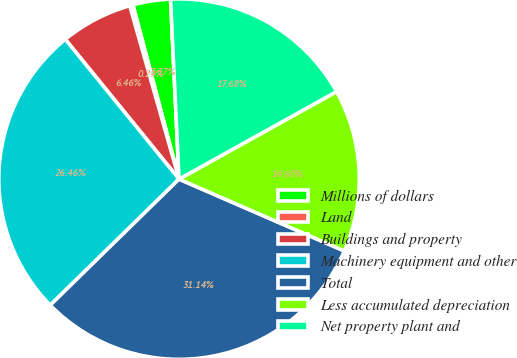Convert chart to OTSL. <chart><loc_0><loc_0><loc_500><loc_500><pie_chart><fcel>Millions of dollars<fcel>Land<fcel>Buildings and property<fcel>Machinery equipment and other<fcel>Total<fcel>Less accumulated depreciation<fcel>Net property plant and<nl><fcel>3.37%<fcel>0.29%<fcel>6.46%<fcel>26.46%<fcel>31.14%<fcel>14.6%<fcel>17.68%<nl></chart> 